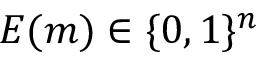<formula> <loc_0><loc_0><loc_500><loc_500>E ( m ) \in \{ 0 , 1 \} ^ { n }</formula> 